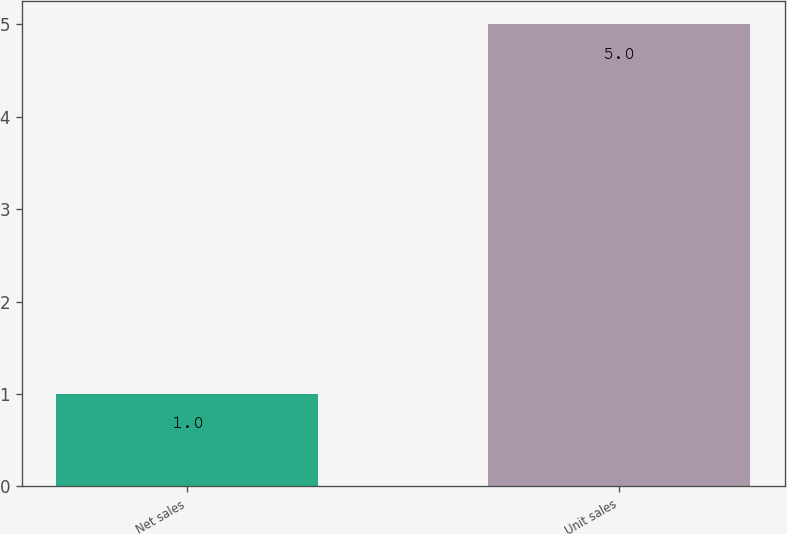<chart> <loc_0><loc_0><loc_500><loc_500><bar_chart><fcel>Net sales<fcel>Unit sales<nl><fcel>1<fcel>5<nl></chart> 